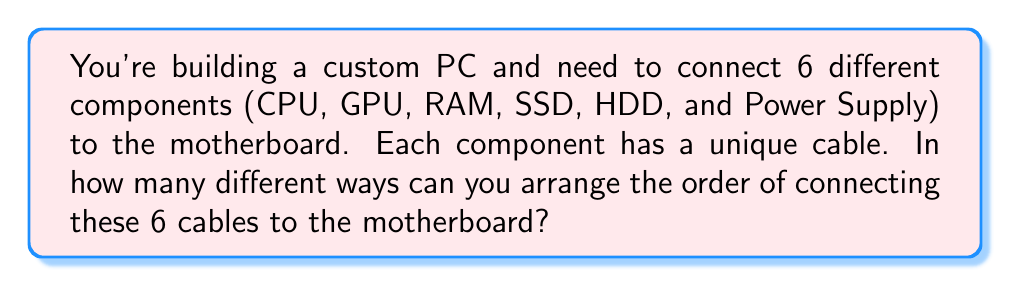Solve this math problem. This problem is a classic example of permutations. We need to find the number of ways to arrange 6 distinct objects (in this case, cables) in a specific order.

The formula for permutations of n distinct objects is:

$$P(n) = n!$$

Where $n!$ represents the factorial of $n$.

In this case, we have 6 distinct cables, so $n = 6$.

Let's calculate step by step:

1) $6! = 6 \times 5 \times 4 \times 3 \times 2 \times 1$

2) $6! = 720$

Therefore, there are 720 different ways to arrange the order of connecting these 6 cables to the motherboard.

This makes sense from a practical standpoint as well. You have:
- 6 choices for the first cable
- 5 choices for the second cable
- 4 choices for the third cable
- 3 choices for the fourth cable
- 2 choices for the fifth cable
- Only 1 choice left for the last cable

Multiplying these together: $6 \times 5 \times 4 \times 3 \times 2 \times 1 = 720$
Answer: 720 